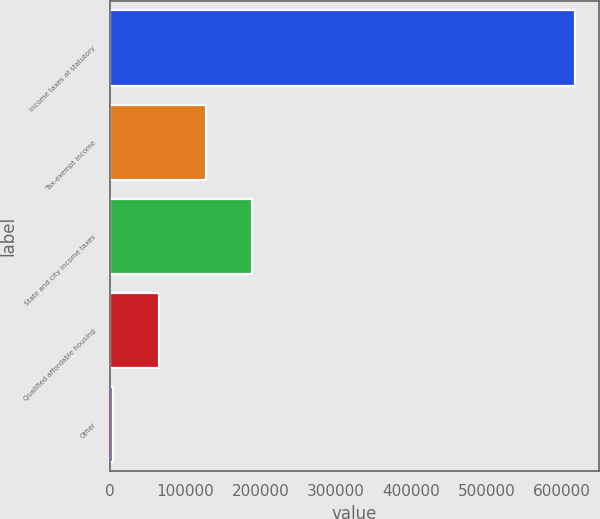Convert chart. <chart><loc_0><loc_0><loc_500><loc_500><bar_chart><fcel>Income taxes at statutory<fcel>Tax-exempt income<fcel>State and city income taxes<fcel>Qualified affordable housing<fcel>Other<nl><fcel>617949<fcel>126753<fcel>188152<fcel>65353.5<fcel>3954<nl></chart> 